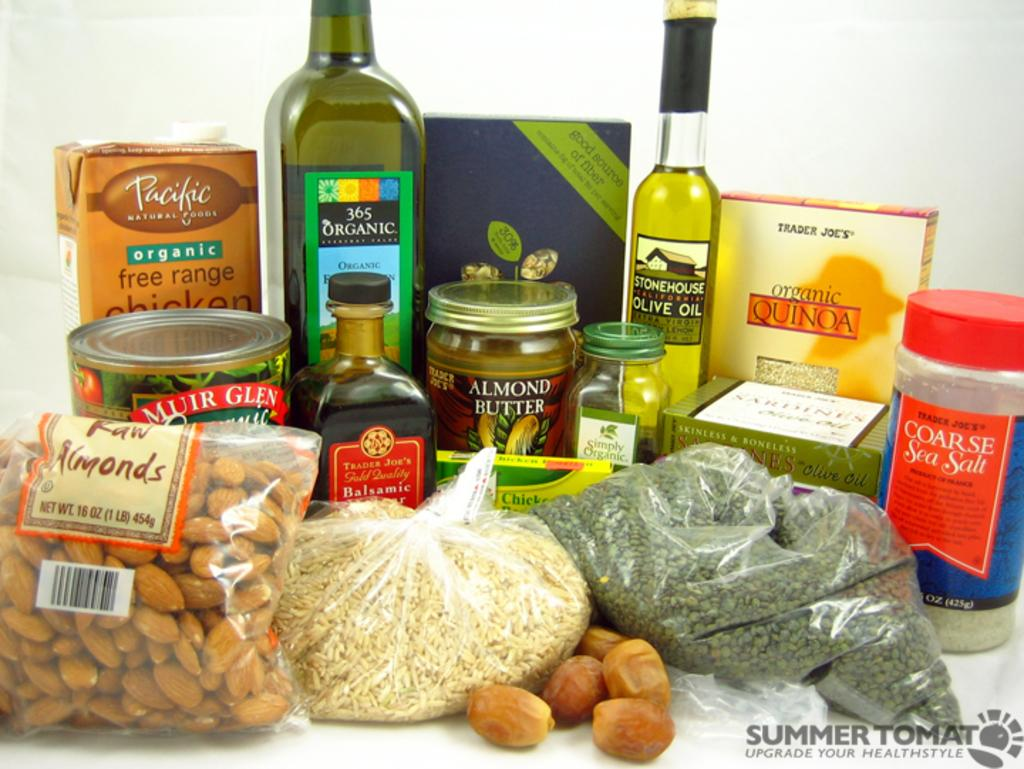<image>
Present a compact description of the photo's key features. A 1lb bag of raw almonds sits next to a bag of rice 